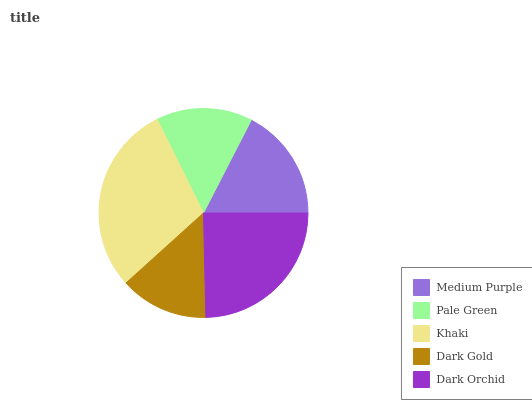Is Dark Gold the minimum?
Answer yes or no. Yes. Is Khaki the maximum?
Answer yes or no. Yes. Is Pale Green the minimum?
Answer yes or no. No. Is Pale Green the maximum?
Answer yes or no. No. Is Medium Purple greater than Pale Green?
Answer yes or no. Yes. Is Pale Green less than Medium Purple?
Answer yes or no. Yes. Is Pale Green greater than Medium Purple?
Answer yes or no. No. Is Medium Purple less than Pale Green?
Answer yes or no. No. Is Medium Purple the high median?
Answer yes or no. Yes. Is Medium Purple the low median?
Answer yes or no. Yes. Is Khaki the high median?
Answer yes or no. No. Is Dark Gold the low median?
Answer yes or no. No. 